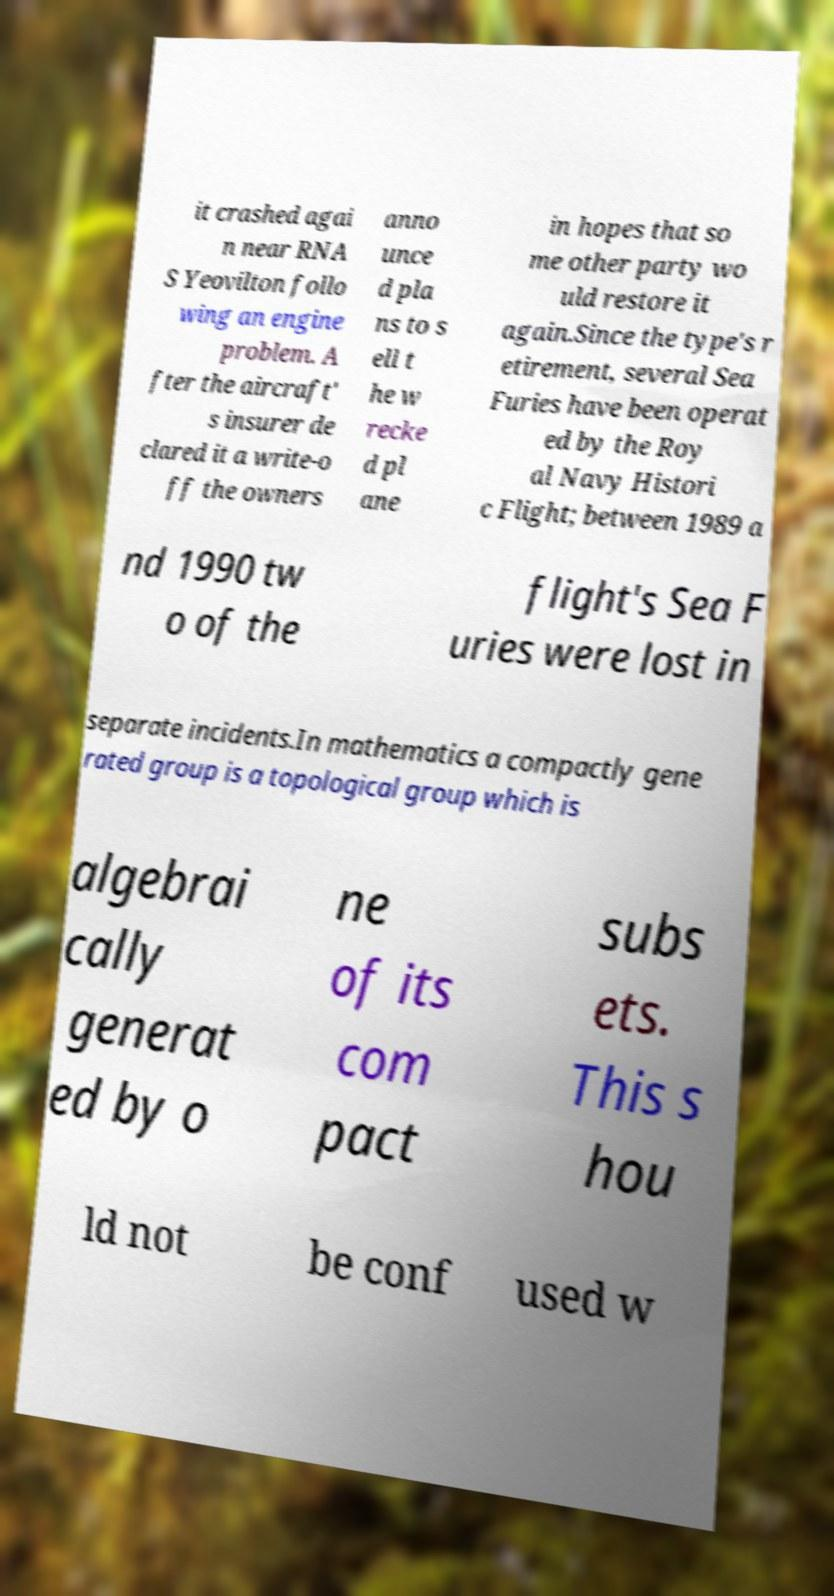Please identify and transcribe the text found in this image. it crashed agai n near RNA S Yeovilton follo wing an engine problem. A fter the aircraft' s insurer de clared it a write-o ff the owners anno unce d pla ns to s ell t he w recke d pl ane in hopes that so me other party wo uld restore it again.Since the type's r etirement, several Sea Furies have been operat ed by the Roy al Navy Histori c Flight; between 1989 a nd 1990 tw o of the flight's Sea F uries were lost in separate incidents.In mathematics a compactly gene rated group is a topological group which is algebrai cally generat ed by o ne of its com pact subs ets. This s hou ld not be conf used w 